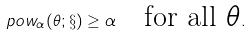<formula> <loc_0><loc_0><loc_500><loc_500>\ p o w _ { \alpha } ( \theta ; \S ) \geq \alpha \quad \text {for all $\theta$} .</formula> 